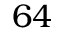Convert formula to latex. <formula><loc_0><loc_0><loc_500><loc_500>6 4</formula> 